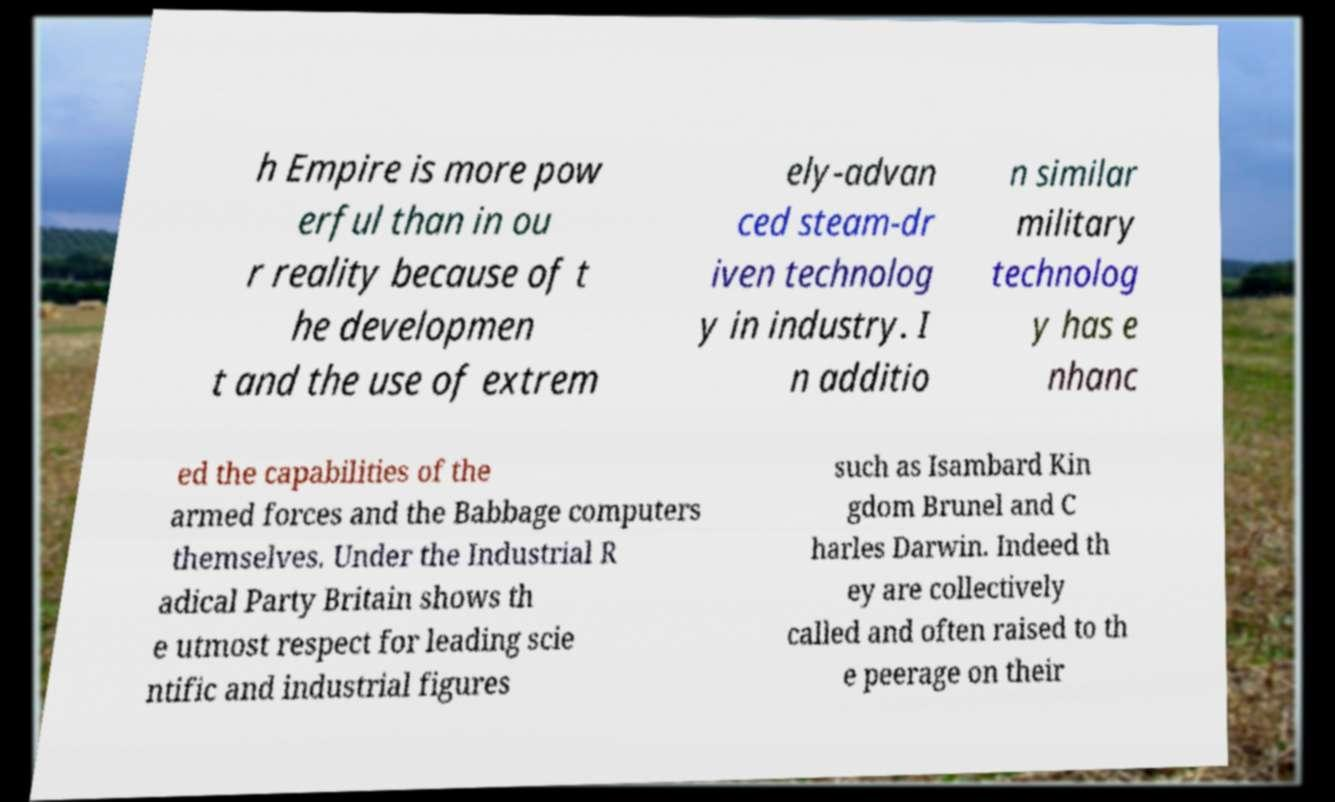Can you accurately transcribe the text from the provided image for me? h Empire is more pow erful than in ou r reality because of t he developmen t and the use of extrem ely-advan ced steam-dr iven technolog y in industry. I n additio n similar military technolog y has e nhanc ed the capabilities of the armed forces and the Babbage computers themselves. Under the Industrial R adical Party Britain shows th e utmost respect for leading scie ntific and industrial figures such as Isambard Kin gdom Brunel and C harles Darwin. Indeed th ey are collectively called and often raised to th e peerage on their 